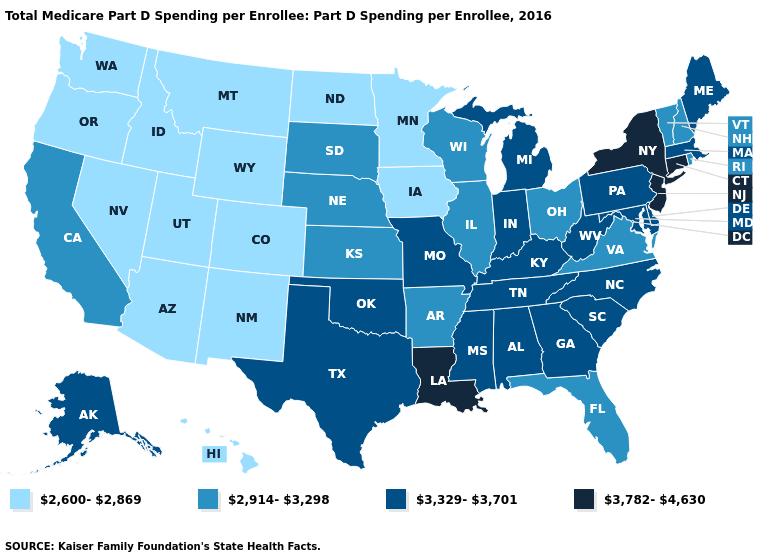What is the highest value in the West ?
Answer briefly. 3,329-3,701. What is the lowest value in the Northeast?
Short answer required. 2,914-3,298. Does Massachusetts have the highest value in the USA?
Answer briefly. No. Does Tennessee have the lowest value in the USA?
Quick response, please. No. Among the states that border New Mexico , does Oklahoma have the lowest value?
Be succinct. No. Does Oklahoma have the same value as Idaho?
Quick response, please. No. Among the states that border Oregon , which have the highest value?
Answer briefly. California. Which states have the lowest value in the West?
Answer briefly. Arizona, Colorado, Hawaii, Idaho, Montana, Nevada, New Mexico, Oregon, Utah, Washington, Wyoming. Name the states that have a value in the range 2,914-3,298?
Be succinct. Arkansas, California, Florida, Illinois, Kansas, Nebraska, New Hampshire, Ohio, Rhode Island, South Dakota, Vermont, Virginia, Wisconsin. What is the value of Delaware?
Short answer required. 3,329-3,701. Does Pennsylvania have a higher value than Wyoming?
Answer briefly. Yes. Is the legend a continuous bar?
Give a very brief answer. No. Does Wyoming have a higher value than New Hampshire?
Concise answer only. No. What is the value of North Carolina?
Answer briefly. 3,329-3,701. Which states hav the highest value in the South?
Concise answer only. Louisiana. 